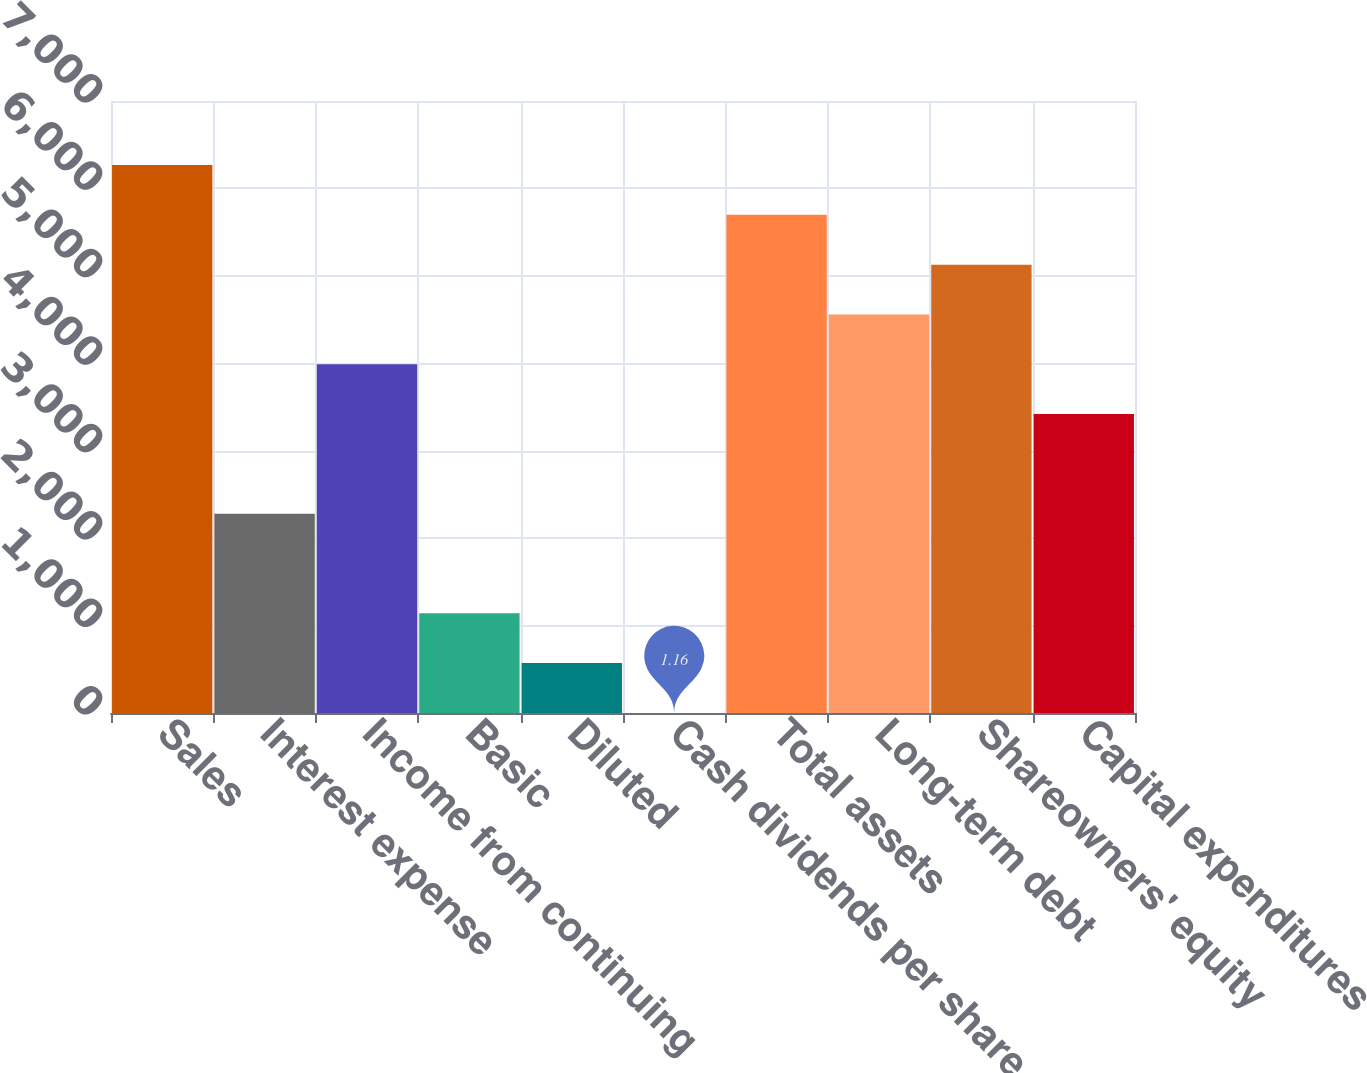Convert chart to OTSL. <chart><loc_0><loc_0><loc_500><loc_500><bar_chart><fcel>Sales<fcel>Interest expense<fcel>Income from continuing<fcel>Basic<fcel>Diluted<fcel>Cash dividends per share<fcel>Total assets<fcel>Long-term debt<fcel>Shareowners' equity<fcel>Capital expenditures<nl><fcel>6267.42<fcel>2279.8<fcel>3988.78<fcel>1140.48<fcel>570.82<fcel>1.16<fcel>5697.76<fcel>4558.44<fcel>5128.1<fcel>3419.12<nl></chart> 